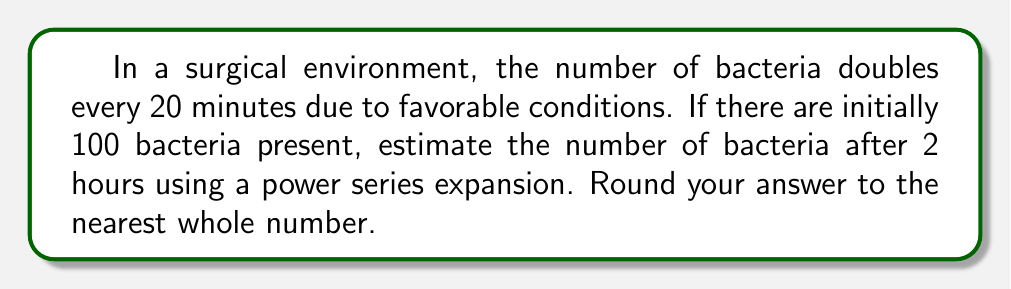Provide a solution to this math problem. Let's approach this step-by-step:

1) First, we need to determine how many 20-minute intervals are in 2 hours:
   2 hours = 120 minutes
   Number of intervals = 120 / 20 = 6

2) Let's define our variables:
   $a_0 = 100$ (initial number of bacteria)
   $r = 2$ (growth rate per interval)
   $n = 6$ (number of intervals)

3) The number of bacteria after $n$ intervals is given by:
   $a_n = a_0 \cdot r^n = 100 \cdot 2^6$

4) We can expand this using the binomial theorem:
   $2^6 = 1 + 6 + 15 + 20 + 15 + 6 + 1 = 64$

5) Therefore, the number of bacteria after 2 hours is:
   $100 \cdot 64 = 6400$

6) The power series expansion for $2^6$ is:
   $$2^6 = \sum_{k=0}^6 \binom{6}{k} = \binom{6}{0} + \binom{6}{1} + \binom{6}{2} + \binom{6}{3} + \binom{6}{4} + \binom{6}{5} + \binom{6}{6}$$

7) This expands to:
   $$2^6 = 1 + 6 + 15 + 20 + 15 + 6 + 1 = 64$$

8) Multiplying by the initial number of bacteria:
   $100 \cdot 64 = 6400$

Therefore, the estimated number of bacteria after 2 hours is 6400.
Answer: 6400 bacteria 